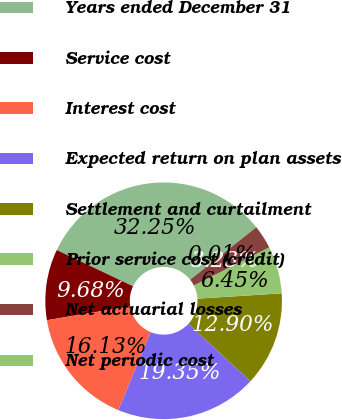Convert chart. <chart><loc_0><loc_0><loc_500><loc_500><pie_chart><fcel>Years ended December 31<fcel>Service cost<fcel>Interest cost<fcel>Expected return on plan assets<fcel>Settlement and curtailment<fcel>Prior service cost (credit)<fcel>Net actuarial losses<fcel>Net periodic cost<nl><fcel>32.25%<fcel>9.68%<fcel>16.13%<fcel>19.35%<fcel>12.9%<fcel>6.45%<fcel>3.23%<fcel>0.01%<nl></chart> 